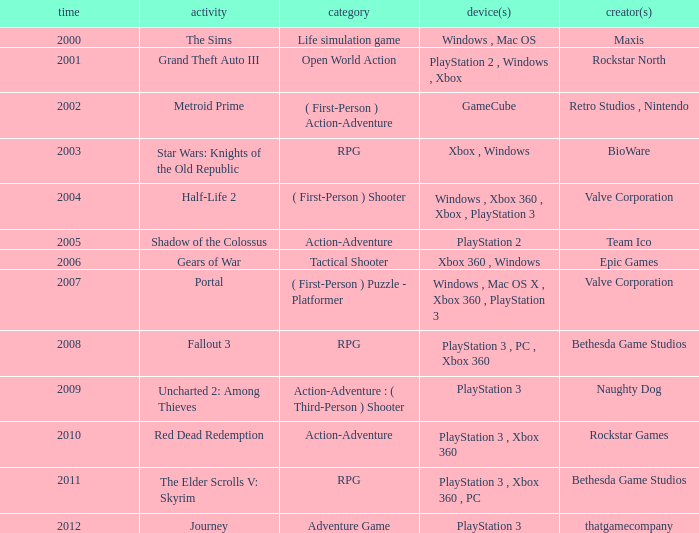Parse the table in full. {'header': ['time', 'activity', 'category', 'device(s)', 'creator(s)'], 'rows': [['2000', 'The Sims', 'Life simulation game', 'Windows , Mac OS', 'Maxis'], ['2001', 'Grand Theft Auto III', 'Open World Action', 'PlayStation 2 , Windows , Xbox', 'Rockstar North'], ['2002', 'Metroid Prime', '( First-Person ) Action-Adventure', 'GameCube', 'Retro Studios , Nintendo'], ['2003', 'Star Wars: Knights of the Old Republic', 'RPG', 'Xbox , Windows', 'BioWare'], ['2004', 'Half-Life 2', '( First-Person ) Shooter', 'Windows , Xbox 360 , Xbox , PlayStation 3', 'Valve Corporation'], ['2005', 'Shadow of the Colossus', 'Action-Adventure', 'PlayStation 2', 'Team Ico'], ['2006', 'Gears of War', 'Tactical Shooter', 'Xbox 360 , Windows', 'Epic Games'], ['2007', 'Portal', '( First-Person ) Puzzle - Platformer', 'Windows , Mac OS X , Xbox 360 , PlayStation 3', 'Valve Corporation'], ['2008', 'Fallout 3', 'RPG', 'PlayStation 3 , PC , Xbox 360', 'Bethesda Game Studios'], ['2009', 'Uncharted 2: Among Thieves', 'Action-Adventure : ( Third-Person ) Shooter', 'PlayStation 3', 'Naughty Dog'], ['2010', 'Red Dead Redemption', 'Action-Adventure', 'PlayStation 3 , Xbox 360', 'Rockstar Games'], ['2011', 'The Elder Scrolls V: Skyrim', 'RPG', 'PlayStation 3 , Xbox 360 , PC', 'Bethesda Game Studios'], ['2012', 'Journey', 'Adventure Game', 'PlayStation 3', 'thatgamecompany']]} What's the platform that has Rockstar Games as the developer? PlayStation 3 , Xbox 360. 